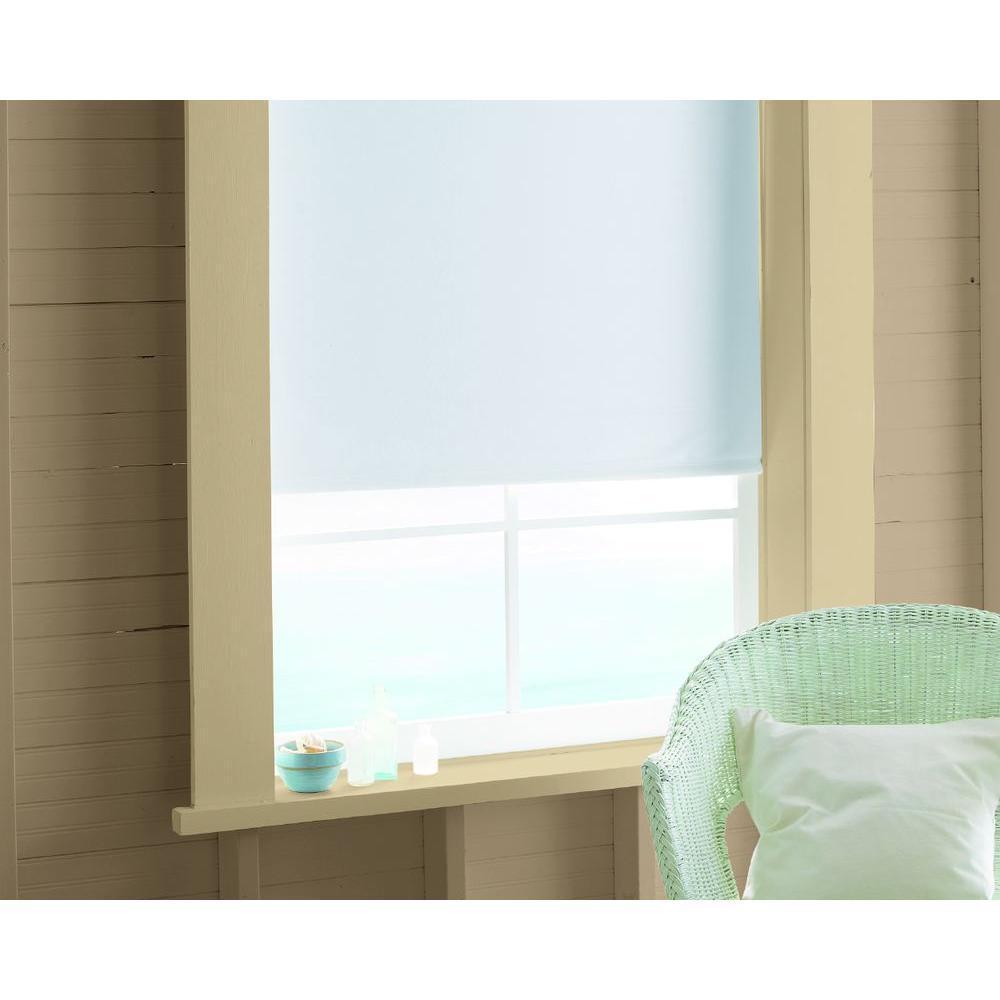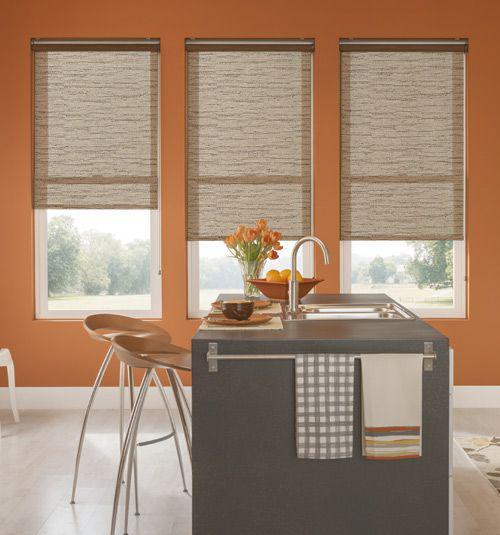The first image is the image on the left, the second image is the image on the right. Given the left and right images, does the statement "A single brown chair is located near a window with a shade in the image on the right." hold true? Answer yes or no. No. The first image is the image on the left, the second image is the image on the right. For the images displayed, is the sentence "There are exactly two window shades." factually correct? Answer yes or no. No. 